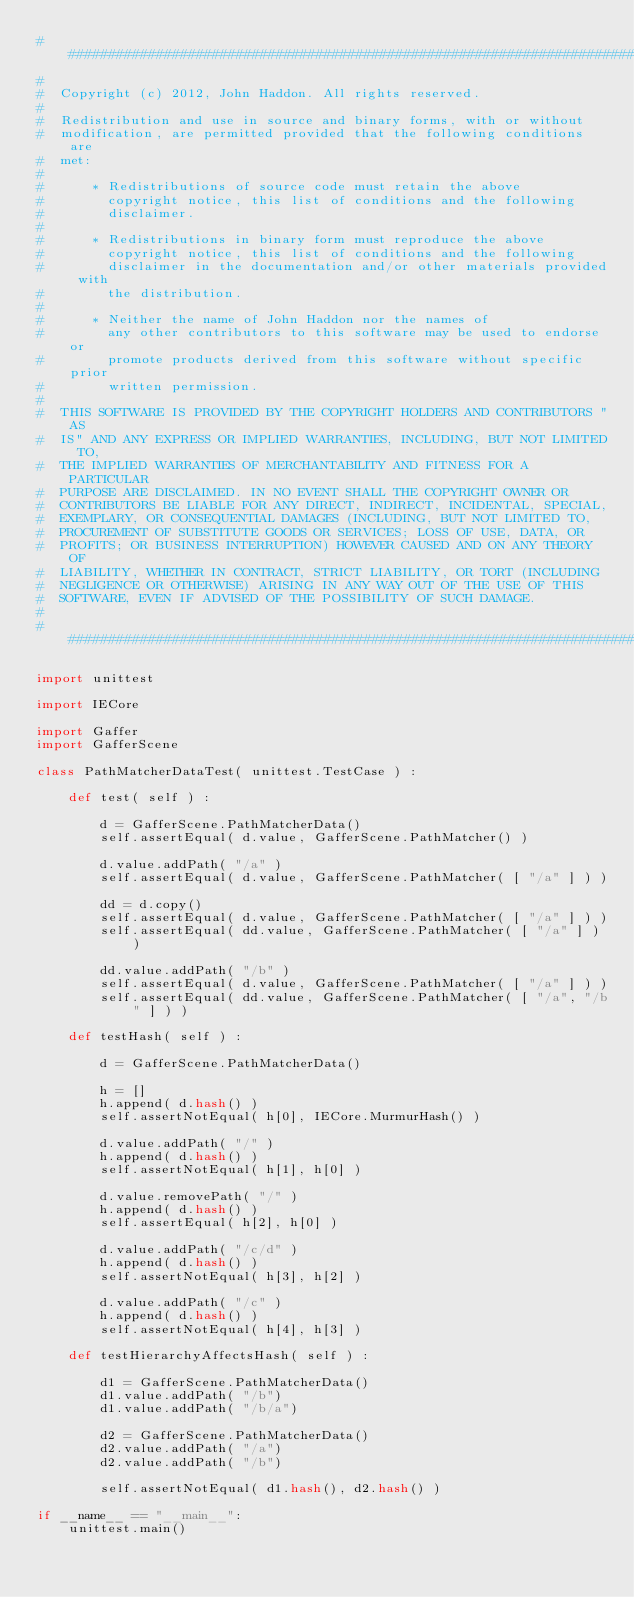Convert code to text. <code><loc_0><loc_0><loc_500><loc_500><_Python_>##########################################################################
#
#  Copyright (c) 2012, John Haddon. All rights reserved.
#
#  Redistribution and use in source and binary forms, with or without
#  modification, are permitted provided that the following conditions are
#  met:
#
#      * Redistributions of source code must retain the above
#        copyright notice, this list of conditions and the following
#        disclaimer.
#
#      * Redistributions in binary form must reproduce the above
#        copyright notice, this list of conditions and the following
#        disclaimer in the documentation and/or other materials provided with
#        the distribution.
#
#      * Neither the name of John Haddon nor the names of
#        any other contributors to this software may be used to endorse or
#        promote products derived from this software without specific prior
#        written permission.
#
#  THIS SOFTWARE IS PROVIDED BY THE COPYRIGHT HOLDERS AND CONTRIBUTORS "AS
#  IS" AND ANY EXPRESS OR IMPLIED WARRANTIES, INCLUDING, BUT NOT LIMITED TO,
#  THE IMPLIED WARRANTIES OF MERCHANTABILITY AND FITNESS FOR A PARTICULAR
#  PURPOSE ARE DISCLAIMED. IN NO EVENT SHALL THE COPYRIGHT OWNER OR
#  CONTRIBUTORS BE LIABLE FOR ANY DIRECT, INDIRECT, INCIDENTAL, SPECIAL,
#  EXEMPLARY, OR CONSEQUENTIAL DAMAGES (INCLUDING, BUT NOT LIMITED TO,
#  PROCUREMENT OF SUBSTITUTE GOODS OR SERVICES; LOSS OF USE, DATA, OR
#  PROFITS; OR BUSINESS INTERRUPTION) HOWEVER CAUSED AND ON ANY THEORY OF
#  LIABILITY, WHETHER IN CONTRACT, STRICT LIABILITY, OR TORT (INCLUDING
#  NEGLIGENCE OR OTHERWISE) ARISING IN ANY WAY OUT OF THE USE OF THIS
#  SOFTWARE, EVEN IF ADVISED OF THE POSSIBILITY OF SUCH DAMAGE.
#
##########################################################################

import unittest

import IECore

import Gaffer
import GafferScene

class PathMatcherDataTest( unittest.TestCase ) :

	def test( self ) :

		d = GafferScene.PathMatcherData()
		self.assertEqual( d.value, GafferScene.PathMatcher() )

		d.value.addPath( "/a" )
		self.assertEqual( d.value, GafferScene.PathMatcher( [ "/a" ] ) )

		dd = d.copy()
		self.assertEqual( d.value, GafferScene.PathMatcher( [ "/a" ] ) )
		self.assertEqual( dd.value, GafferScene.PathMatcher( [ "/a" ] ) )

		dd.value.addPath( "/b" )
		self.assertEqual( d.value, GafferScene.PathMatcher( [ "/a" ] ) )
		self.assertEqual( dd.value, GafferScene.PathMatcher( [ "/a", "/b" ] ) )

	def testHash( self ) :

		d = GafferScene.PathMatcherData()

		h = []
		h.append( d.hash() )
		self.assertNotEqual( h[0], IECore.MurmurHash() )

		d.value.addPath( "/" )
		h.append( d.hash() )
		self.assertNotEqual( h[1], h[0] )

		d.value.removePath( "/" )
		h.append( d.hash() )
		self.assertEqual( h[2], h[0] )

		d.value.addPath( "/c/d" )
		h.append( d.hash() )
		self.assertNotEqual( h[3], h[2] )

		d.value.addPath( "/c" )
		h.append( d.hash() )
		self.assertNotEqual( h[4], h[3] )

	def testHierarchyAffectsHash( self ) :

		d1 = GafferScene.PathMatcherData()
		d1.value.addPath( "/b")
		d1.value.addPath( "/b/a")

		d2 = GafferScene.PathMatcherData()
		d2.value.addPath( "/a")
		d2.value.addPath( "/b")

		self.assertNotEqual( d1.hash(), d2.hash() )

if __name__ == "__main__":
	unittest.main()
</code> 